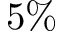<formula> <loc_0><loc_0><loc_500><loc_500>5 \%</formula> 